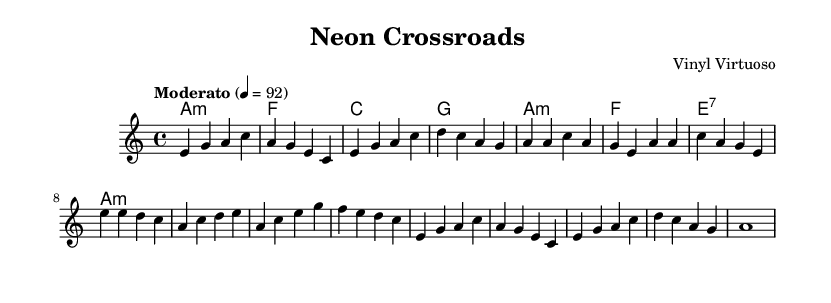What is the key signature of this music? The key signature is A minor, which has no sharps or flats.
Answer: A minor What is the time signature of the piece? The time signature shown is 4/4, indicating four beats per measure.
Answer: 4/4 What is the tempo marking of this composition? The tempo marking indicates a "Moderato" speed, specifically set at 92 beats per minute.
Answer: Moderato 92 How many measures are in the verse section? The verse is comprised of two identical measures repeated, counted as two measures total.
Answer: 2 measures What chord is played during the bridge section? The bridge section starts with an A minor chord, as indicated in the harmonies.
Answer: A minor How does this song convey elements of contemporary indie-blues fusion? The use of rhythmic modulation between traditional blues structures and experimental electronic influences is evident through the combination of melody and harmonies.
Answer: Fusion of styles What type of electronic elements might be inferred from this piece? Given its modern context, the electronic elements could include synthesized sounds or samples layered over the traditional blues format, creating an experimental atmosphere.
Answer: Experimental electronic 